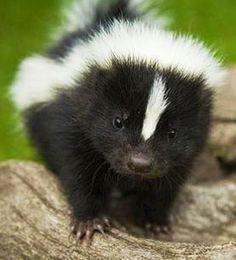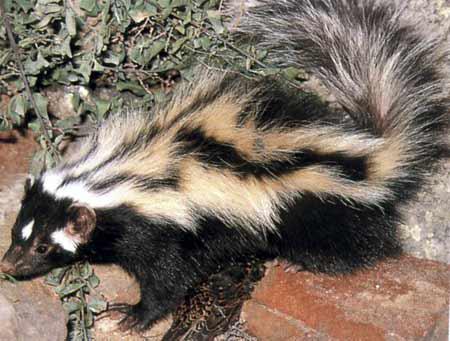The first image is the image on the left, the second image is the image on the right. For the images shown, is this caption "At least one skunk is in the grass." true? Answer yes or no. No. The first image is the image on the left, the second image is the image on the right. Examine the images to the left and right. Is the description "The left image contains one forward-facing skunk, and the right image includes a skunk on all fours with its body turned leftward." accurate? Answer yes or no. Yes. 